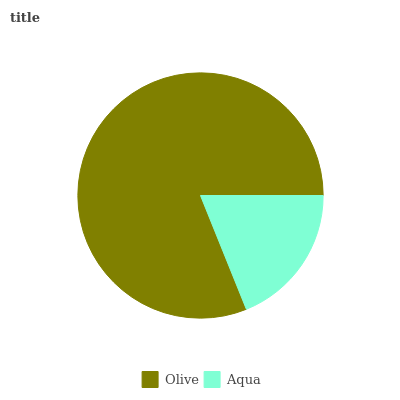Is Aqua the minimum?
Answer yes or no. Yes. Is Olive the maximum?
Answer yes or no. Yes. Is Aqua the maximum?
Answer yes or no. No. Is Olive greater than Aqua?
Answer yes or no. Yes. Is Aqua less than Olive?
Answer yes or no. Yes. Is Aqua greater than Olive?
Answer yes or no. No. Is Olive less than Aqua?
Answer yes or no. No. Is Olive the high median?
Answer yes or no. Yes. Is Aqua the low median?
Answer yes or no. Yes. Is Aqua the high median?
Answer yes or no. No. Is Olive the low median?
Answer yes or no. No. 